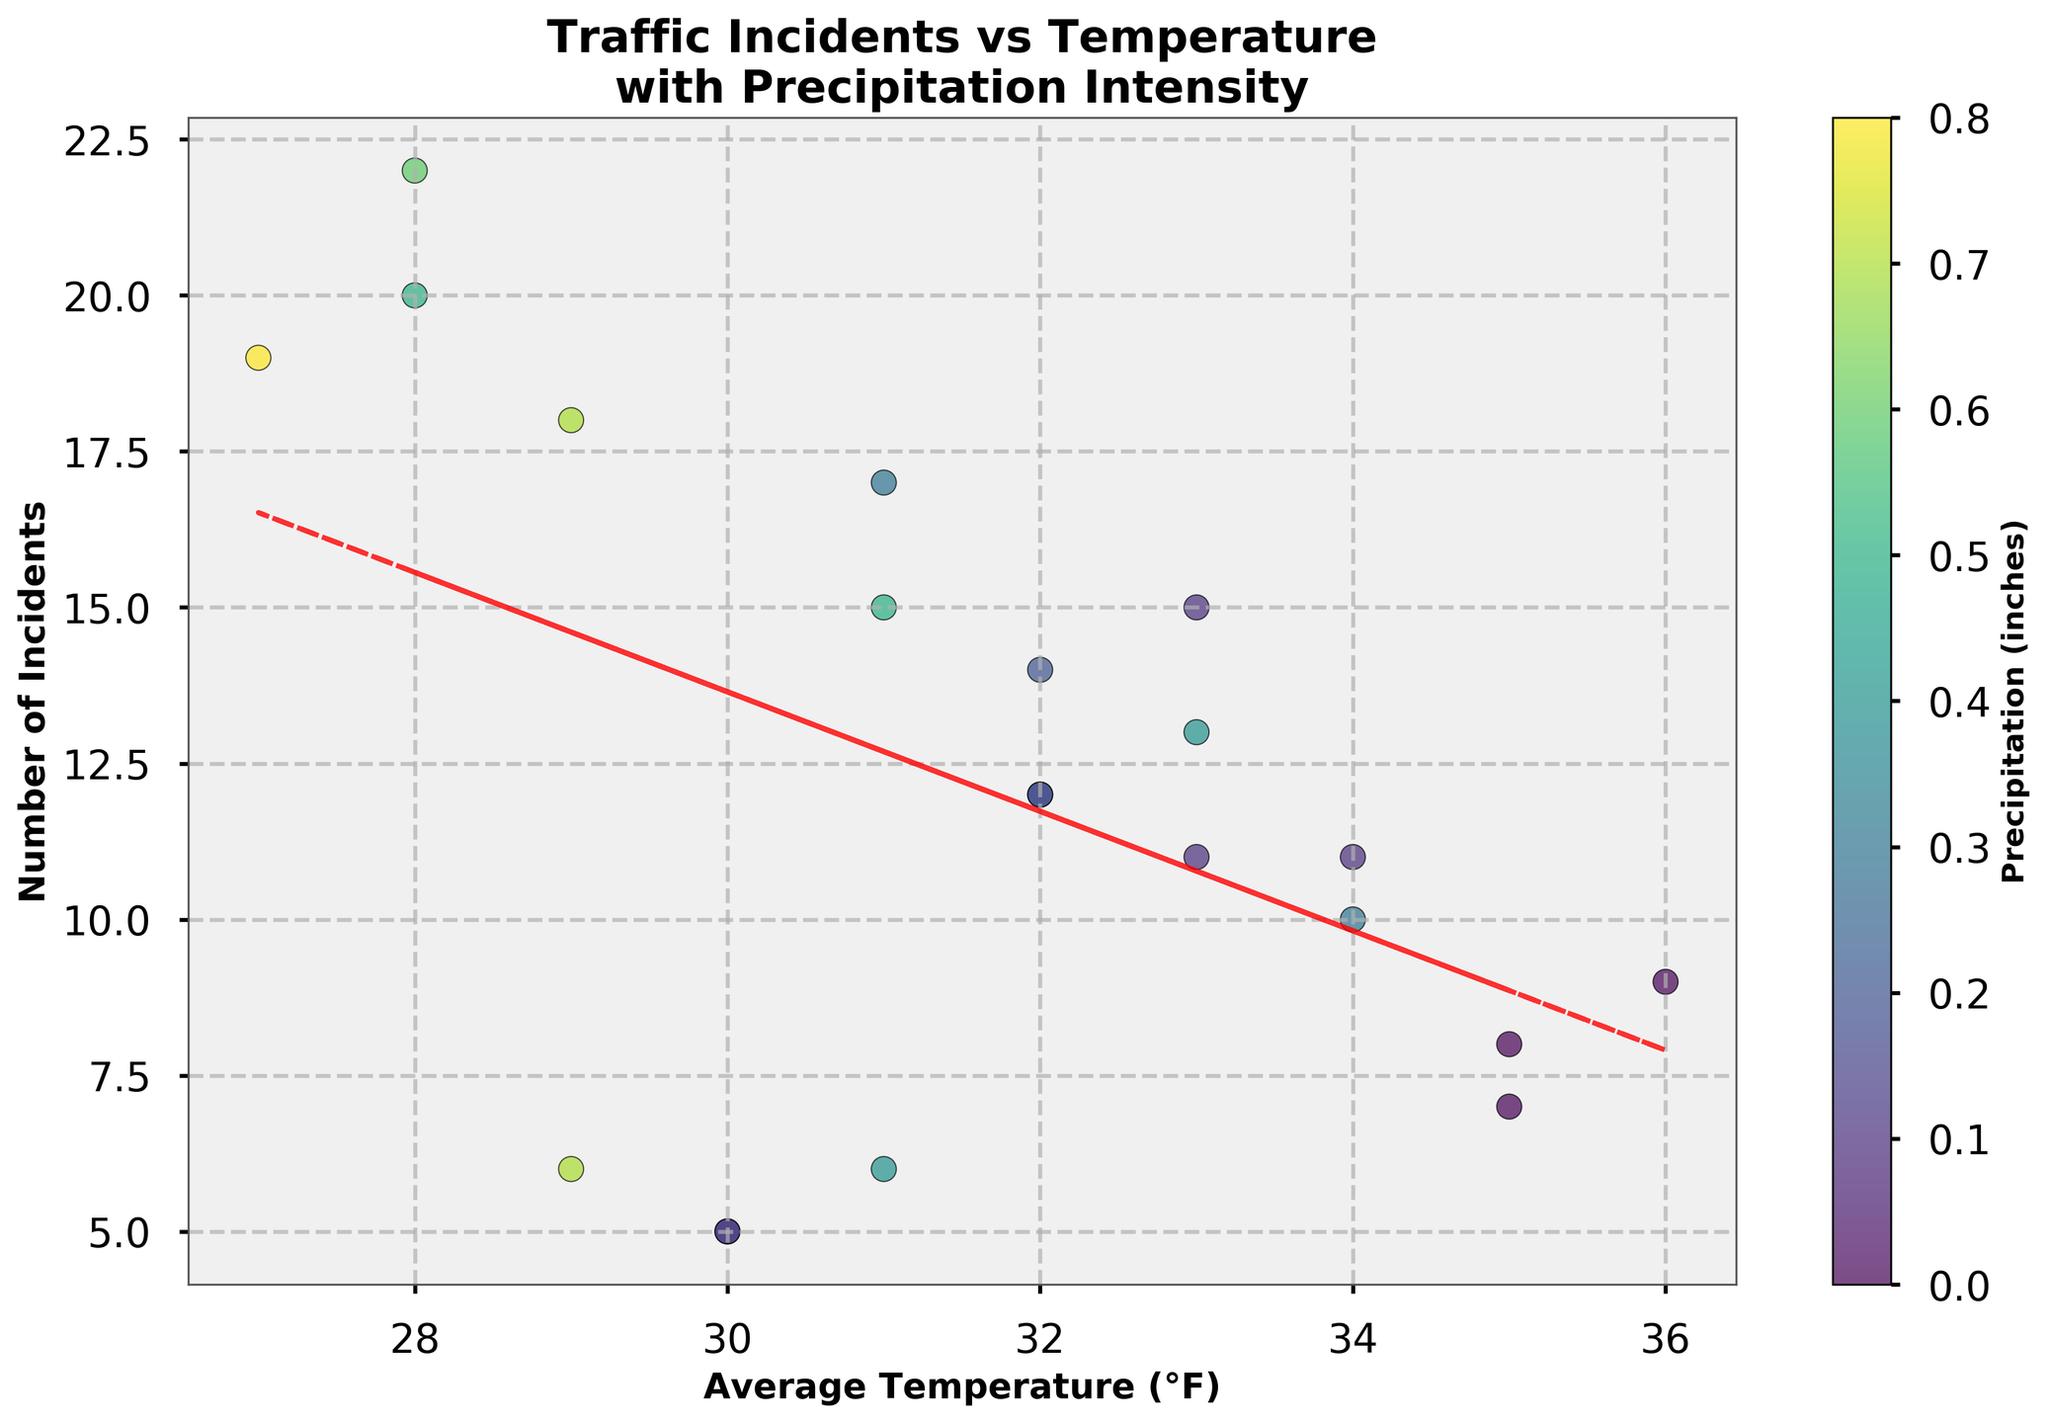What is the title of the plot? The title is usually found at the top of the plot and describes what the figure is about. Here it says "Traffic Incidents vs Temperature\nwith Precipitation Intensity."
Answer: Traffic Incidents vs Temperature with Precipitation Intensity What are the labels of the X and Y axes? The X-axis label is usually at the bottom, and the Y-axis label is on the left side of the figure. Here they are 'Average Temperature (°F)' for the X-axis and 'Number of Incidents' for the Y-axis.
Answer: Average Temperature (°F) and Number of Incidents What does the color of the points represent? The color of the points can be understood by looking at the color bar, which typically indicates the intensity of another variable. In this case, it represents 'Precipitation (inches).'
Answer: Precipitation (inches) How many data points are there in the plot? We count the individual points on the scatter plot. Based on the dataset given, there should be 21 points corresponding to the 21 entries.
Answer: 21 Is the relationship between average temperature and the number of incidents positive or negative? By looking at the trend line on the scatter plot, we can see the general direction. The line's slope indicates whether the relationship is positive (upward) or negative (downward). Here the trend line slightly slopes downward, indicating a negative relationship.
Answer: Negative Which location had the most traffic incidents and what was the average temperature when it happened? We can find the highest point on the Y-axis and see its corresponding X-axis value. The point at Y=22 corresponds to the data point for Eastside with an average temperature of 28°F.
Answer: Eastside, 28°F Which data point has the highest precipitation value, and how many incidents were there? The darkest (most intense) color on the scatter plot indicates the highest precipitation. The point with the highest precipitation (0.8 inches) corresponds to 19 incidents, located at Eastside.
Answer: 19 incidents Did Downtown see more incidents when the temperature was lower or higher? By locating points with 'Downtown' on the scatter plot and comparing their positions on the X-axis (temperature), we see that Downtown had more incidents (15) when the temperature was 31°F compared to other days with higher temperatures.
Answer: Lower In general, how does precipitation intensity appear to correlate with the number of traffic incidents? Observing the scatter plot and how the darker points (higher precipitation) are distributed, we see that higher precipitation tends to correspond with more incidents.
Answer: Higher precipitation correlates with more incidents Which temperature range appears to have the most variation in the number of incidents? By grouping the scatter points into temperature ranges on the X-axis and observing the spread of the Y-axis values within those ranges, we can infer that the 28-31°F range has the most variation with incidents ranging from 6 to 22.
Answer: 28-31°F 